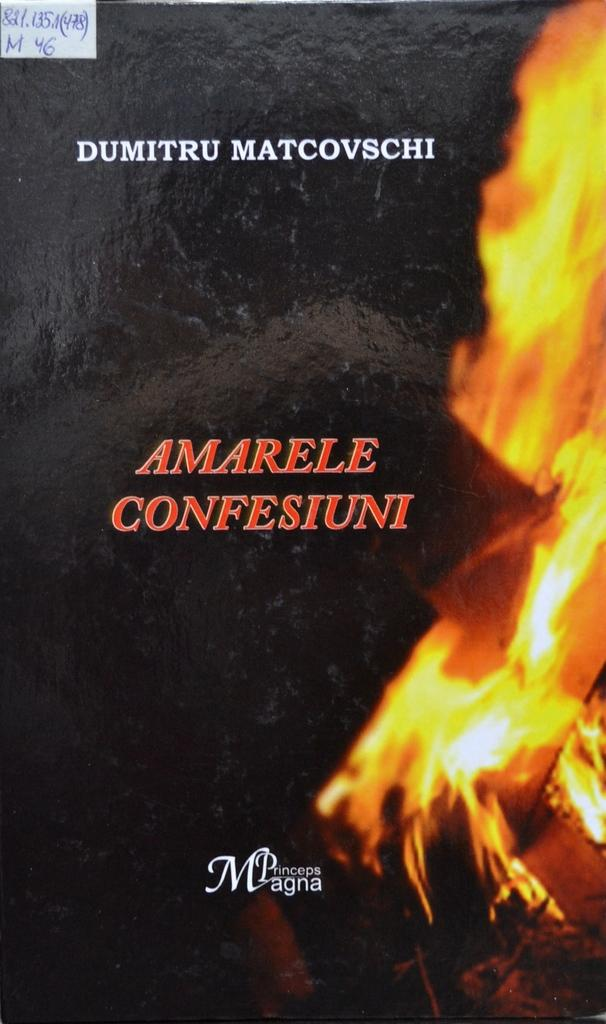<image>
Render a clear and concise summary of the photo. Cover that says "Amarele Confesiuni" in red and the word Princeps Magna on the bottom. 